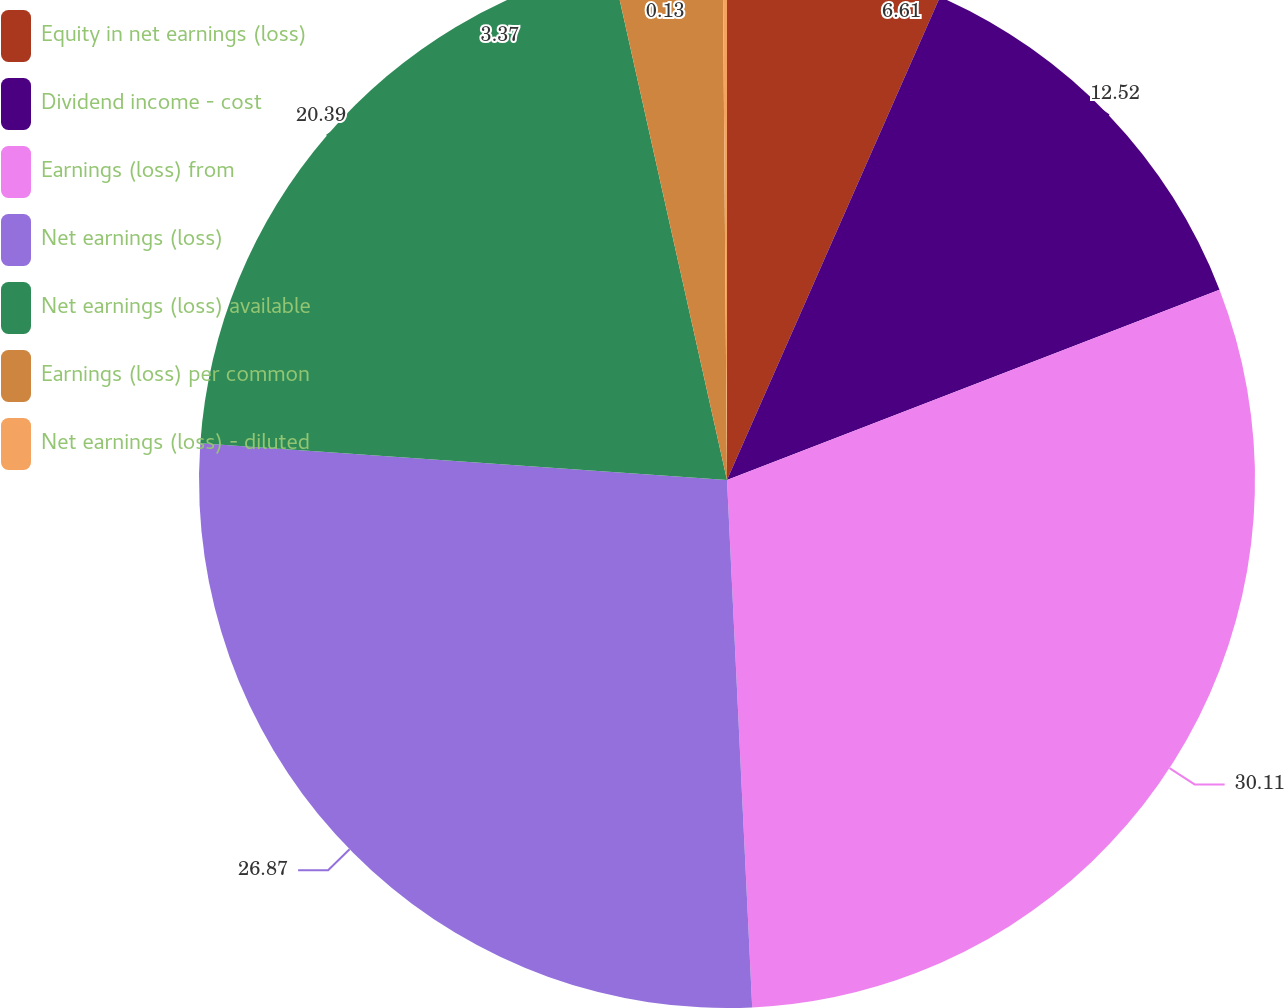<chart> <loc_0><loc_0><loc_500><loc_500><pie_chart><fcel>Equity in net earnings (loss)<fcel>Dividend income - cost<fcel>Earnings (loss) from<fcel>Net earnings (loss)<fcel>Net earnings (loss) available<fcel>Earnings (loss) per common<fcel>Net earnings (loss) - diluted<nl><fcel>6.61%<fcel>12.52%<fcel>30.11%<fcel>26.87%<fcel>20.39%<fcel>3.37%<fcel>0.13%<nl></chart> 